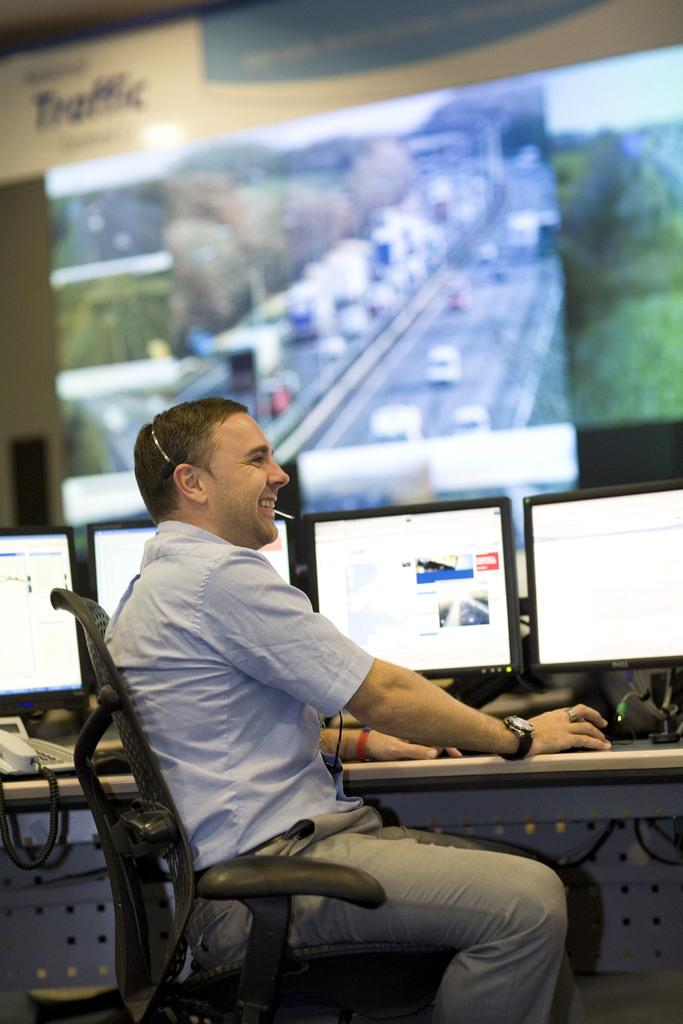What is the main subject of the image? The main subject of the image is a man. What is the man doing in the image? The man is sitting in a chair and operating a computer. How is the man feeling in the image? The man is smiling, which suggests he is happy or content. Where is the computer located in the image? The computer is on a table. What can be seen on the screen in the background of the image? The screen displays a city. What type of plastic material is the writer using to create their work in the image? There is no writer or plastic material present in the image; it features a man operating a computer. 